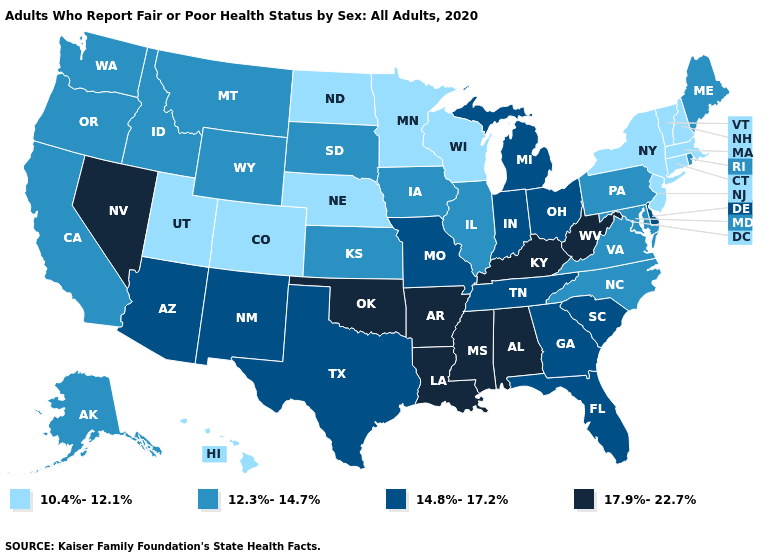What is the highest value in states that border Indiana?
Keep it brief. 17.9%-22.7%. Is the legend a continuous bar?
Concise answer only. No. What is the highest value in states that border South Carolina?
Short answer required. 14.8%-17.2%. Does Tennessee have a higher value than Nebraska?
Be succinct. Yes. Which states have the lowest value in the USA?
Be succinct. Colorado, Connecticut, Hawaii, Massachusetts, Minnesota, Nebraska, New Hampshire, New Jersey, New York, North Dakota, Utah, Vermont, Wisconsin. Does North Dakota have the lowest value in the MidWest?
Keep it brief. Yes. Does the first symbol in the legend represent the smallest category?
Short answer required. Yes. Among the states that border Ohio , does Kentucky have the highest value?
Keep it brief. Yes. What is the lowest value in states that border South Carolina?
Answer briefly. 12.3%-14.7%. Does Arizona have the lowest value in the USA?
Write a very short answer. No. Among the states that border Pennsylvania , which have the highest value?
Quick response, please. West Virginia. What is the lowest value in states that border North Carolina?
Short answer required. 12.3%-14.7%. What is the value of Illinois?
Write a very short answer. 12.3%-14.7%. What is the value of Oklahoma?
Answer briefly. 17.9%-22.7%. Name the states that have a value in the range 17.9%-22.7%?
Answer briefly. Alabama, Arkansas, Kentucky, Louisiana, Mississippi, Nevada, Oklahoma, West Virginia. 